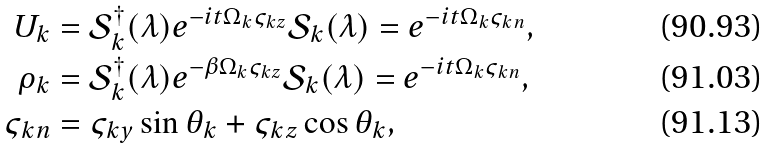Convert formula to latex. <formula><loc_0><loc_0><loc_500><loc_500>U _ { k } & = \mathcal { S } ^ { \dag } _ { k } ( \lambda ) e ^ { - i t \Omega _ { k } \varsigma _ { k z } } \mathcal { S } _ { k } ( \lambda ) = e ^ { - i t \Omega _ { k } \varsigma _ { k n } } , \\ \rho _ { k } & = \mathcal { S } _ { k } ^ { \dag } ( \lambda ) e ^ { - \beta \Omega _ { k } \varsigma _ { k z } } \mathcal { S } _ { k } ( \lambda ) = e ^ { - i t \Omega _ { k } \varsigma _ { k n } } , \\ \varsigma _ { k n } & = \varsigma _ { k y } \sin \theta _ { k } + \varsigma _ { k z } \cos \theta _ { k } ,</formula> 